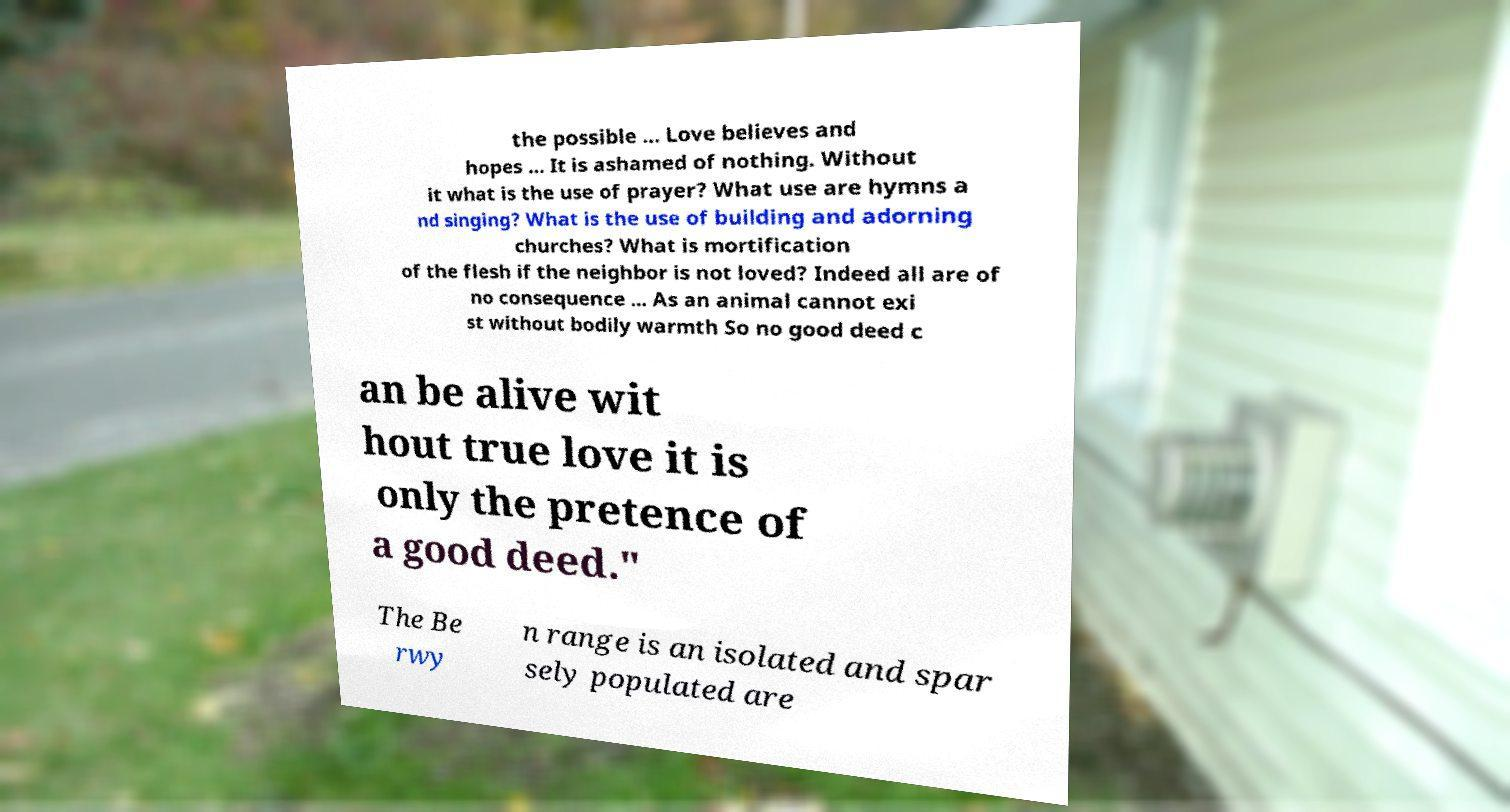Can you read and provide the text displayed in the image?This photo seems to have some interesting text. Can you extract and type it out for me? the possible ... Love believes and hopes ... It is ashamed of nothing. Without it what is the use of prayer? What use are hymns a nd singing? What is the use of building and adorning churches? What is mortification of the flesh if the neighbor is not loved? Indeed all are of no consequence ... As an animal cannot exi st without bodily warmth So no good deed c an be alive wit hout true love it is only the pretence of a good deed." The Be rwy n range is an isolated and spar sely populated are 